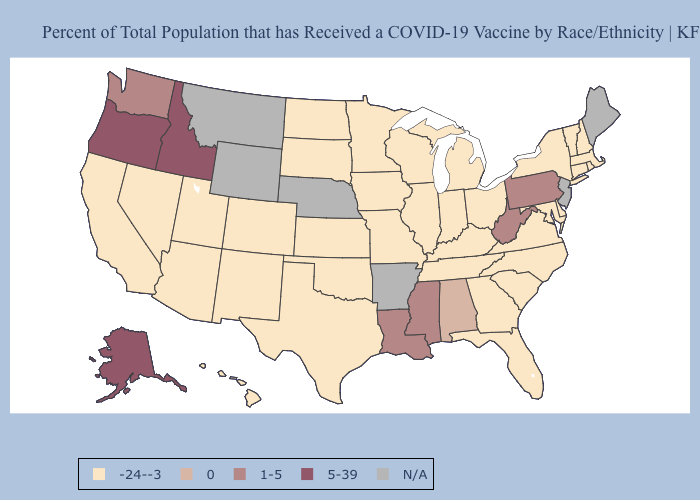Which states have the highest value in the USA?
Keep it brief. Alaska, Idaho, Oregon. Name the states that have a value in the range N/A?
Answer briefly. Arkansas, Maine, Montana, Nebraska, New Jersey, Wyoming. What is the value of Tennessee?
Give a very brief answer. -24--3. Among the states that border Kentucky , which have the lowest value?
Be succinct. Illinois, Indiana, Missouri, Ohio, Tennessee, Virginia. Does New York have the highest value in the Northeast?
Keep it brief. No. What is the highest value in states that border Rhode Island?
Short answer required. -24--3. What is the value of New Hampshire?
Answer briefly. -24--3. Name the states that have a value in the range 5-39?
Answer briefly. Alaska, Idaho, Oregon. Among the states that border Oregon , does California have the lowest value?
Quick response, please. Yes. What is the lowest value in the USA?
Give a very brief answer. -24--3. What is the lowest value in the USA?
Concise answer only. -24--3. Does the map have missing data?
Keep it brief. Yes. Does Washington have the lowest value in the West?
Short answer required. No. Does Kansas have the lowest value in the USA?
Be succinct. Yes. Which states hav the highest value in the MidWest?
Keep it brief. Illinois, Indiana, Iowa, Kansas, Michigan, Minnesota, Missouri, North Dakota, Ohio, South Dakota, Wisconsin. 